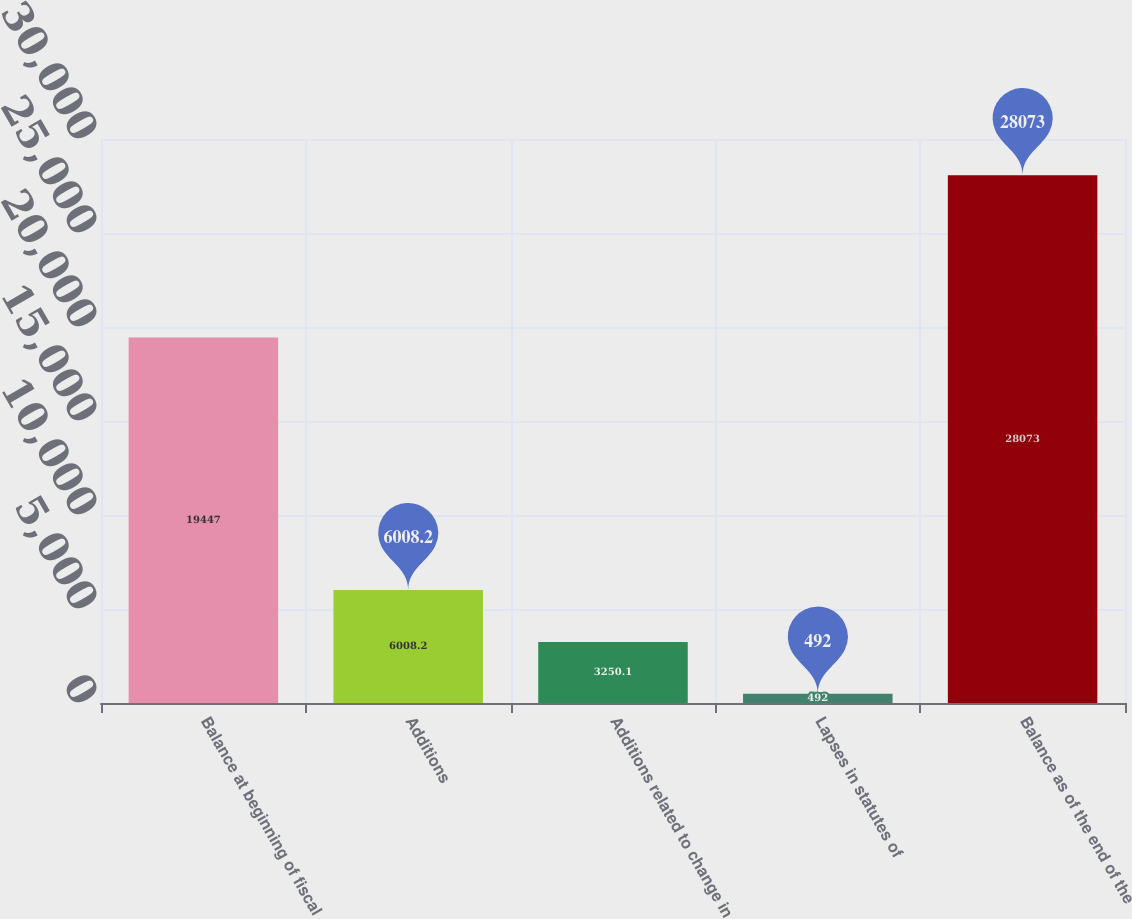Convert chart. <chart><loc_0><loc_0><loc_500><loc_500><bar_chart><fcel>Balance at beginning of fiscal<fcel>Additions<fcel>Additions related to change in<fcel>Lapses in statutes of<fcel>Balance as of the end of the<nl><fcel>19447<fcel>6008.2<fcel>3250.1<fcel>492<fcel>28073<nl></chart> 